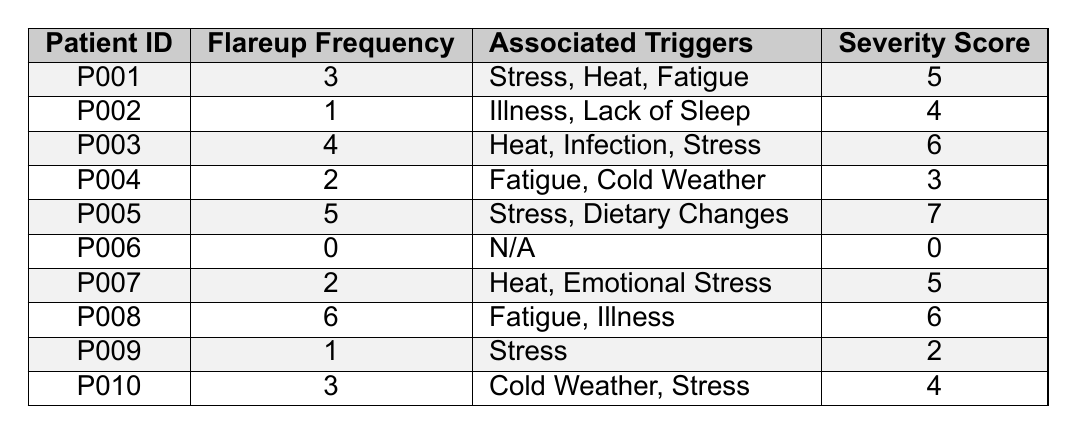What is the flareup frequency for Patient P005? The flareup frequency for Patient P005 is listed directly in the table as 5.
Answer: 5 Which patient has the highest severity score? By examining the severity scores in the table, P005 has the highest score of 7.
Answer: P005 What are the associated triggers for Patient P008? The table shows that Patient P008 has associated triggers of Fatigue and Illness.
Answer: Fatigue, Illness How many patients have a flareup frequency of 2? Looking through the table, I can see P004 and P007 both have a flareup frequency of 2, totaling 2 patients.
Answer: 2 What is the average flareup frequency of all patients? Adding the frequencies (3 + 1 + 4 + 2 + 5 + 0 + 2 + 6 + 1 + 3) = 27, and there are 10 patients, so the average is 27/10 = 2.7.
Answer: 2.7 Do any patients have a flareup frequency of 0? Checking the table, Patient P006 has a flareup frequency of 0.
Answer: Yes Which associated trigger appears most frequently across the patients listed? Reviewing the triggers, "Stress" appears for P001, P003, P005, P007, and P010, making it a common trigger among 5 patients.
Answer: Stress Which patient has a flareup frequency of 4 or more? Evaluating the flareup frequencies, P003 (4), P005 (5), and P008 (6) all have frequencies of 4 or greater.
Answer: P003, P005, P008 What is the total severity score for patients with flareup frequency greater than 3? Patients with frequency greater than 3 are P003 (6), P005 (7), and P008 (6). Summing these scores gives 6 + 7 + 6 = 19.
Answer: 19 Is there a patient whose associated triggers is listed as "N/A"? Looking at the table, Patient P006 has "N/A" listed as their associated triggers.
Answer: Yes 